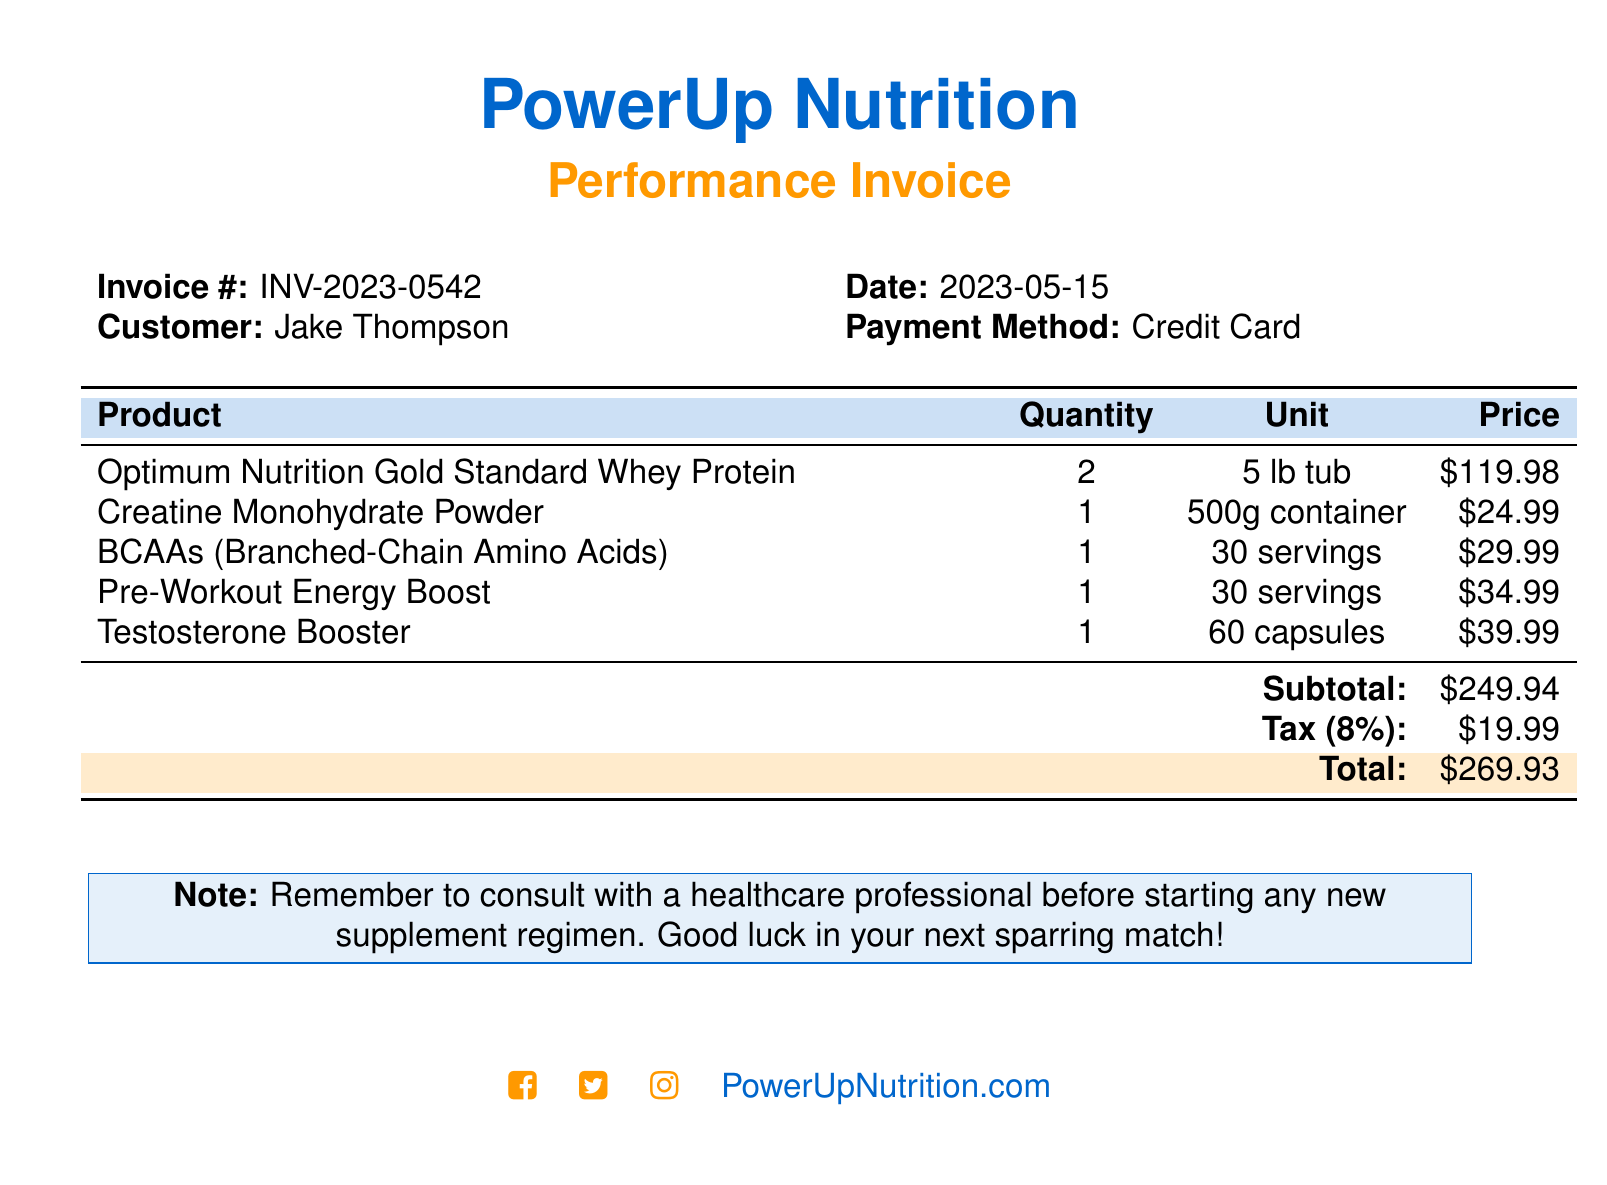What is the invoice number? The invoice number is listed in the document for reference.
Answer: INV-2023-0542 Who is the customer? The document contains the name of the customer being billed.
Answer: Jake Thompson What is the date of the invoice? The specific date of the transaction is mentioned in the document.
Answer: 2023-05-15 What is the total amount due? The total is calculated with the subtotal and tax included.
Answer: $269.93 How many units of Whey Protein were purchased? The quantity of the specific product is provided in the table.
Answer: 2 What percentage is the tax? The tax percentage applied to the subtotal is specified in the document.
Answer: 8% Which product has the highest price? The prices of the products can be compared to determine the highest.
Answer: Optimum Nutrition Gold Standard Whey Protein How many servings does the Pre-Workout Energy Boost contain? The document lists the serving size for this product specifically.
Answer: 30 servings What is noted about consulting a healthcare professional? A note in the document advises on health consultations for supplements.
Answer: Remember to consult with a healthcare professional before starting any new supplement regimen 